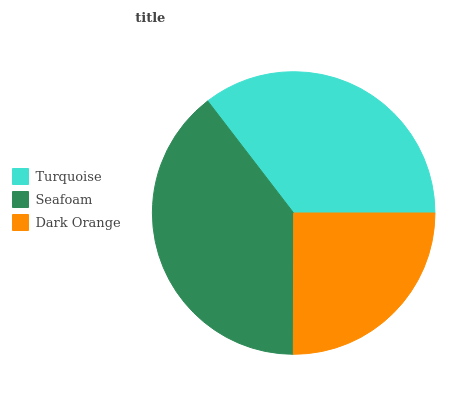Is Dark Orange the minimum?
Answer yes or no. Yes. Is Seafoam the maximum?
Answer yes or no. Yes. Is Seafoam the minimum?
Answer yes or no. No. Is Dark Orange the maximum?
Answer yes or no. No. Is Seafoam greater than Dark Orange?
Answer yes or no. Yes. Is Dark Orange less than Seafoam?
Answer yes or no. Yes. Is Dark Orange greater than Seafoam?
Answer yes or no. No. Is Seafoam less than Dark Orange?
Answer yes or no. No. Is Turquoise the high median?
Answer yes or no. Yes. Is Turquoise the low median?
Answer yes or no. Yes. Is Seafoam the high median?
Answer yes or no. No. Is Dark Orange the low median?
Answer yes or no. No. 